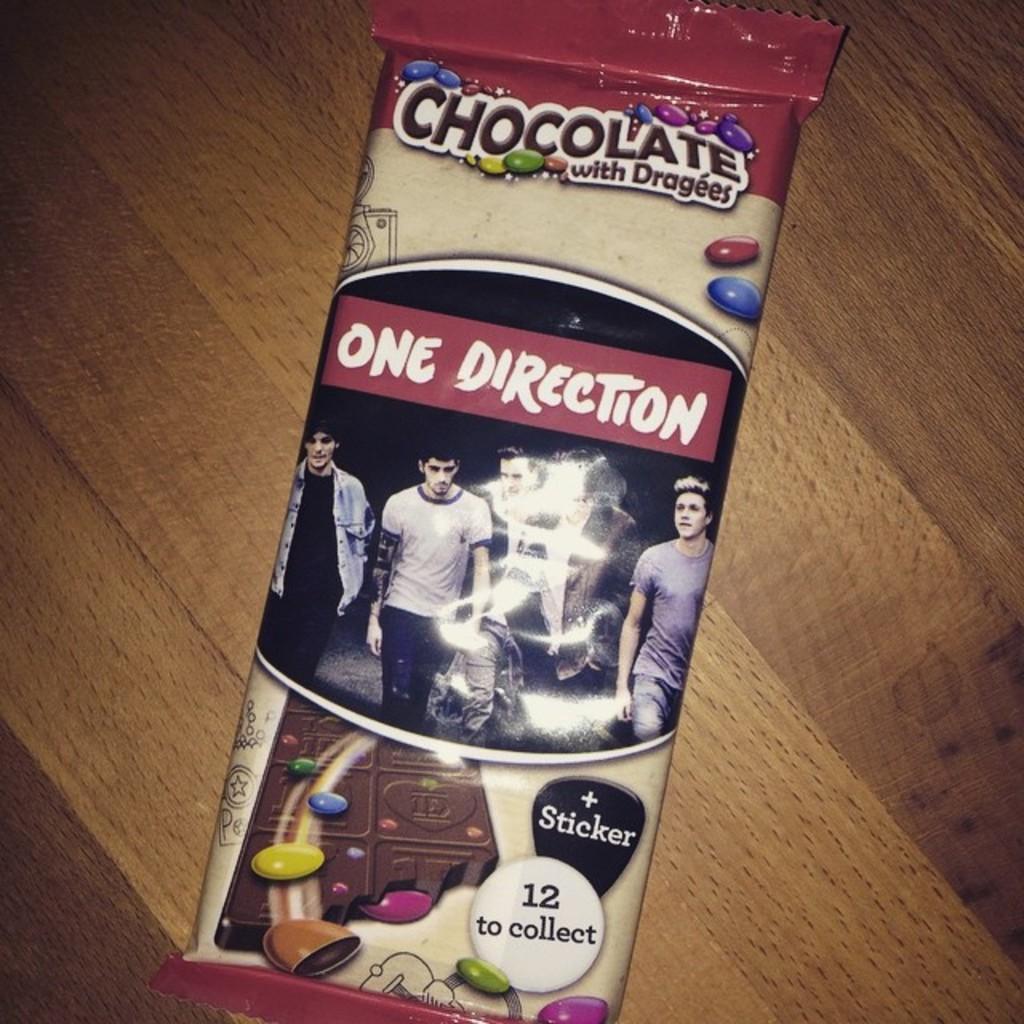Describe this image in one or two sentences. In this image there is a chocolate wrapper on top of a table. 